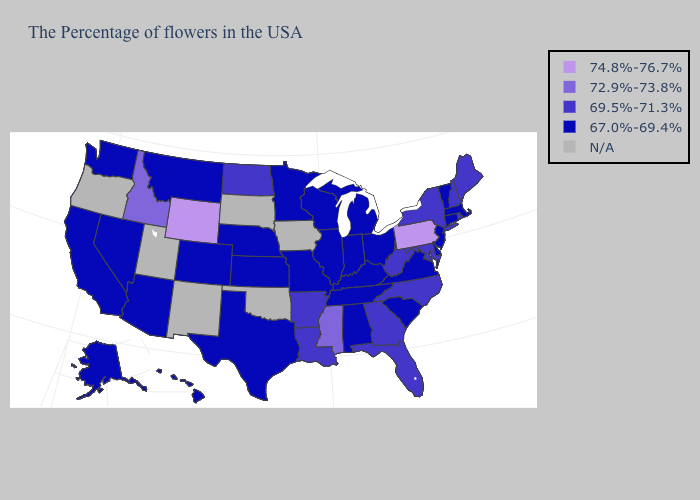Name the states that have a value in the range N/A?
Give a very brief answer. Iowa, Oklahoma, South Dakota, New Mexico, Utah, Oregon. Among the states that border Colorado , does Arizona have the lowest value?
Write a very short answer. Yes. What is the highest value in states that border South Dakota?
Quick response, please. 74.8%-76.7%. Name the states that have a value in the range N/A?
Give a very brief answer. Iowa, Oklahoma, South Dakota, New Mexico, Utah, Oregon. Does Texas have the highest value in the USA?
Keep it brief. No. What is the value of New York?
Quick response, please. 69.5%-71.3%. Among the states that border Florida , does Alabama have the highest value?
Short answer required. No. Name the states that have a value in the range 74.8%-76.7%?
Answer briefly. Pennsylvania, Wyoming. Does Kentucky have the lowest value in the South?
Be succinct. Yes. What is the value of Louisiana?
Quick response, please. 69.5%-71.3%. Name the states that have a value in the range 72.9%-73.8%?
Be succinct. Mississippi, Idaho. Name the states that have a value in the range 74.8%-76.7%?
Be succinct. Pennsylvania, Wyoming. Which states hav the highest value in the MidWest?
Write a very short answer. North Dakota. What is the value of Nebraska?
Give a very brief answer. 67.0%-69.4%. 